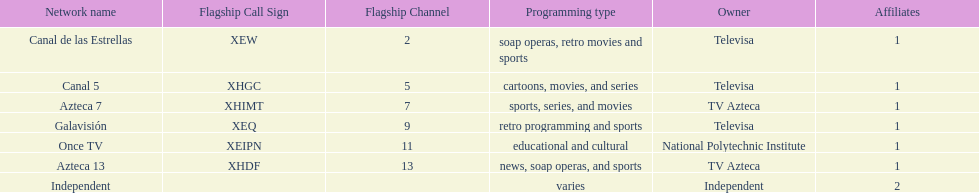What is the only network owned by national polytechnic institute? Once TV. 